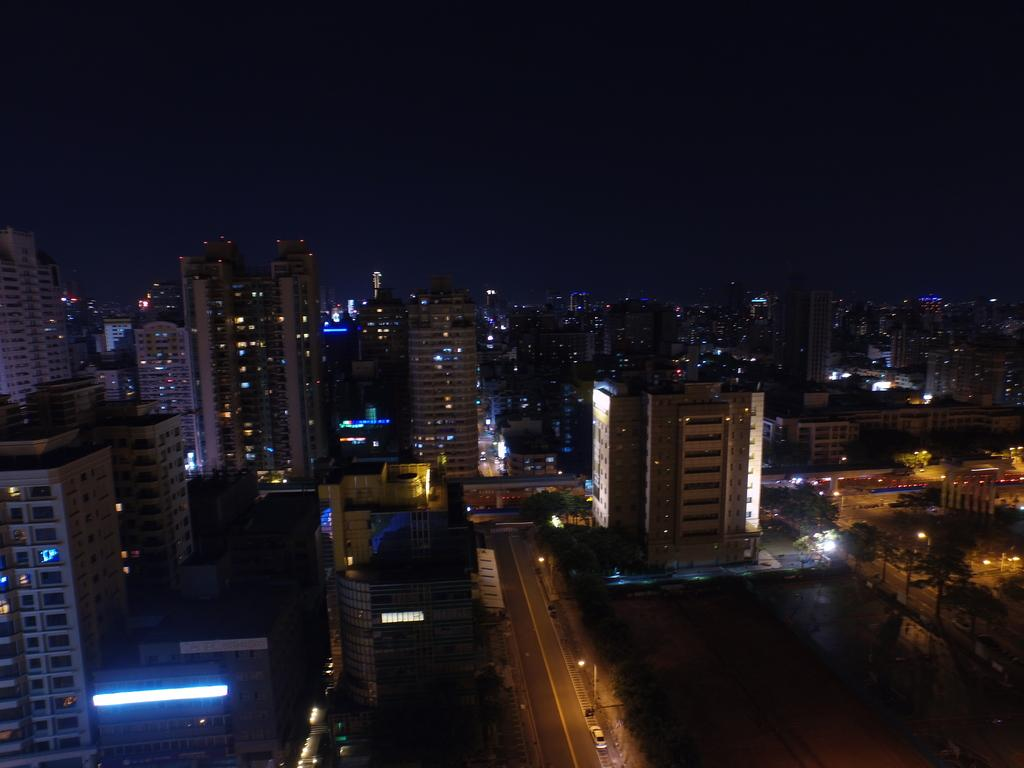What type of structures can be seen in the image? There are buildings in the image. What else can be seen in the image besides buildings? There are poles, lights, trees, and a vehicle in the image. What is the condition of the ground in the image? The ground is visible in the image, and there are objects on it. What is the color of the sky in the image? The sky is dark in the image. Where is the hospital located in the image? There is no hospital present in the image. What type of poison can be seen on the ground in the image? There is no poison present in the image; it is not mentioned in the provided facts. 